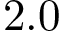<formula> <loc_0><loc_0><loc_500><loc_500>2 . 0</formula> 